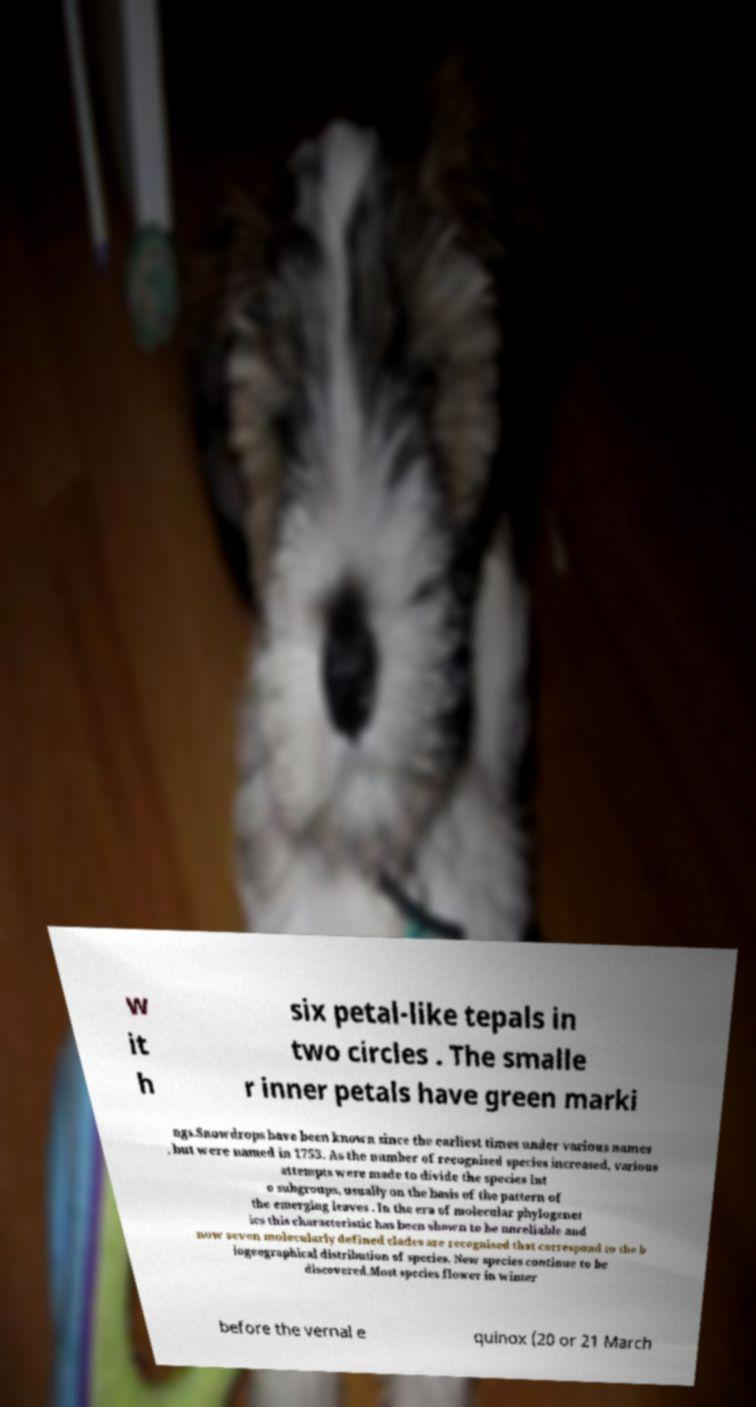Please read and relay the text visible in this image. What does it say? w it h six petal-like tepals in two circles . The smalle r inner petals have green marki ngs.Snowdrops have been known since the earliest times under various names , but were named in 1753. As the number of recognised species increased, various attempts were made to divide the species int o subgroups, usually on the basis of the pattern of the emerging leaves . In the era of molecular phylogenet ics this characteristic has been shown to be unreliable and now seven molecularly defined clades are recognised that correspond to the b iogeographical distribution of species. New species continue to be discovered.Most species flower in winter before the vernal e quinox (20 or 21 March 